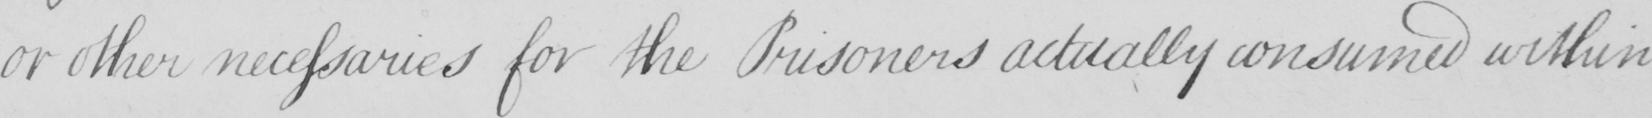Transcribe the text shown in this historical manuscript line. or other necessaries for the Prisoners actually consumed within 